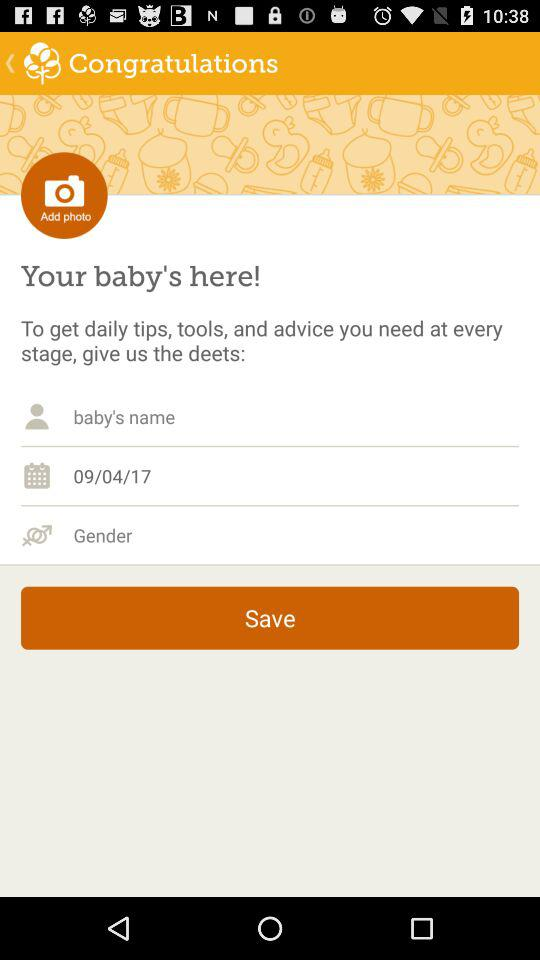What is the date of birth of the baby? The date of birth of the baby is 09/04/17. 